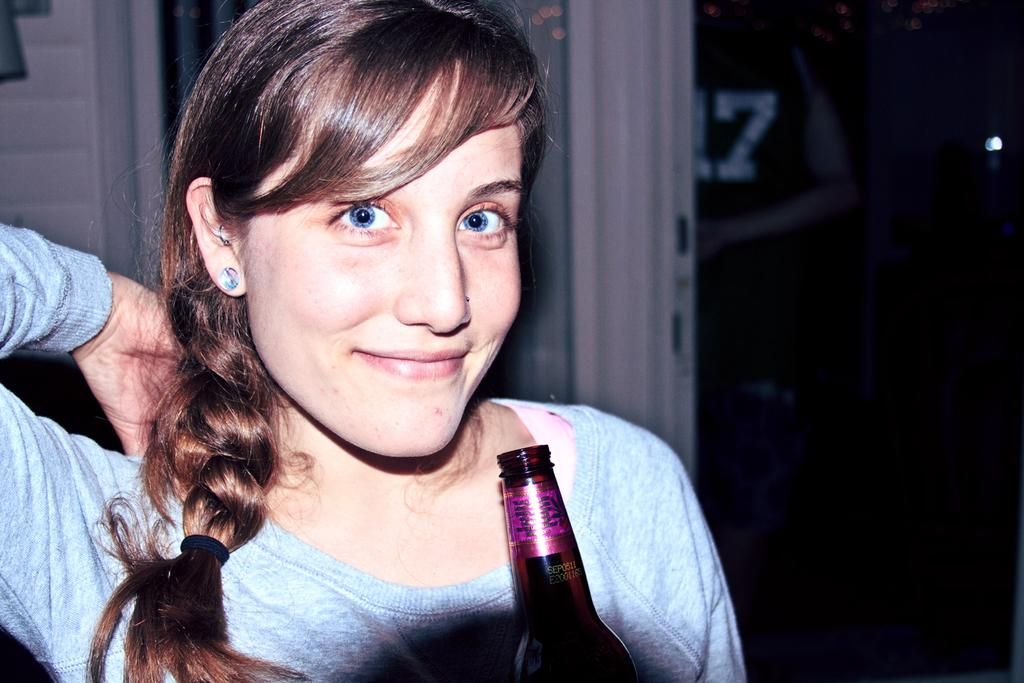What is the main subject of the image? There is a woman in the image. What is the woman holding in the image? The woman is holding a bottle. What expression does the woman have in the image? The woman is smiling. What type of lipstick is the woman wearing on her side in the image? There is no lipstick or mention of a side in the image; the woman is simply smiling and holding a bottle. 